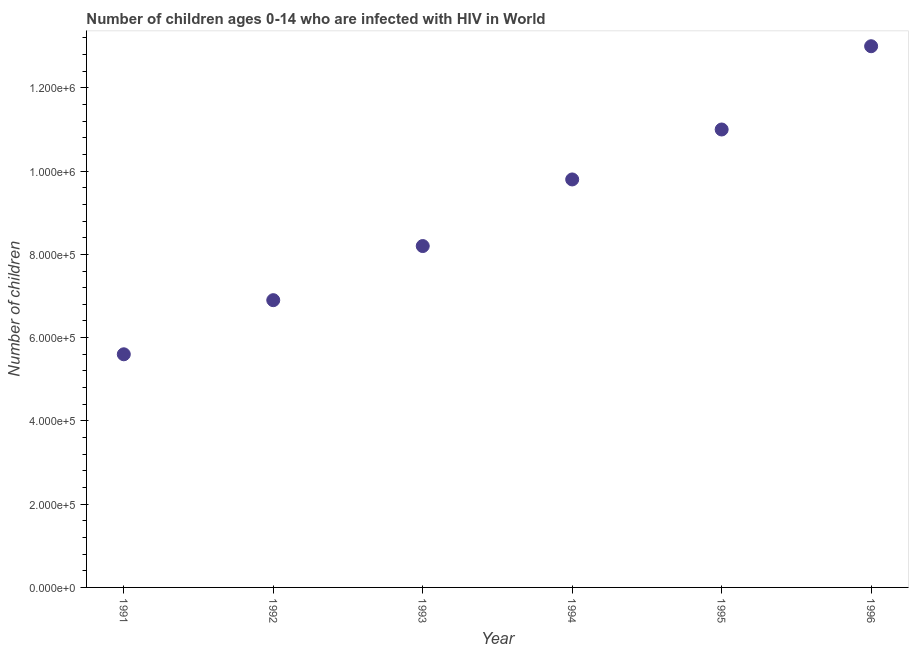What is the number of children living with hiv in 1994?
Offer a terse response. 9.80e+05. Across all years, what is the maximum number of children living with hiv?
Your response must be concise. 1.30e+06. Across all years, what is the minimum number of children living with hiv?
Provide a succinct answer. 5.60e+05. In which year was the number of children living with hiv minimum?
Your answer should be very brief. 1991. What is the sum of the number of children living with hiv?
Your response must be concise. 5.45e+06. What is the difference between the number of children living with hiv in 1995 and 1996?
Your response must be concise. -2.00e+05. What is the average number of children living with hiv per year?
Your answer should be compact. 9.08e+05. In how many years, is the number of children living with hiv greater than 160000 ?
Provide a short and direct response. 6. Do a majority of the years between 1994 and 1993 (inclusive) have number of children living with hiv greater than 160000 ?
Your answer should be very brief. No. What is the ratio of the number of children living with hiv in 1994 to that in 1995?
Make the answer very short. 0.89. Is the number of children living with hiv in 1993 less than that in 1996?
Keep it short and to the point. Yes. What is the difference between the highest and the second highest number of children living with hiv?
Offer a terse response. 2.00e+05. Is the sum of the number of children living with hiv in 1991 and 1996 greater than the maximum number of children living with hiv across all years?
Your answer should be very brief. Yes. What is the difference between the highest and the lowest number of children living with hiv?
Provide a short and direct response. 7.40e+05. Does the number of children living with hiv monotonically increase over the years?
Offer a very short reply. Yes. How many years are there in the graph?
Give a very brief answer. 6. What is the difference between two consecutive major ticks on the Y-axis?
Your response must be concise. 2.00e+05. Does the graph contain any zero values?
Your answer should be compact. No. What is the title of the graph?
Keep it short and to the point. Number of children ages 0-14 who are infected with HIV in World. What is the label or title of the X-axis?
Provide a short and direct response. Year. What is the label or title of the Y-axis?
Provide a succinct answer. Number of children. What is the Number of children in 1991?
Provide a succinct answer. 5.60e+05. What is the Number of children in 1992?
Your answer should be very brief. 6.90e+05. What is the Number of children in 1993?
Make the answer very short. 8.20e+05. What is the Number of children in 1994?
Offer a terse response. 9.80e+05. What is the Number of children in 1995?
Provide a short and direct response. 1.10e+06. What is the Number of children in 1996?
Your answer should be compact. 1.30e+06. What is the difference between the Number of children in 1991 and 1992?
Keep it short and to the point. -1.30e+05. What is the difference between the Number of children in 1991 and 1993?
Give a very brief answer. -2.60e+05. What is the difference between the Number of children in 1991 and 1994?
Keep it short and to the point. -4.20e+05. What is the difference between the Number of children in 1991 and 1995?
Ensure brevity in your answer.  -5.40e+05. What is the difference between the Number of children in 1991 and 1996?
Offer a terse response. -7.40e+05. What is the difference between the Number of children in 1992 and 1993?
Your answer should be compact. -1.30e+05. What is the difference between the Number of children in 1992 and 1995?
Ensure brevity in your answer.  -4.10e+05. What is the difference between the Number of children in 1992 and 1996?
Ensure brevity in your answer.  -6.10e+05. What is the difference between the Number of children in 1993 and 1994?
Provide a succinct answer. -1.60e+05. What is the difference between the Number of children in 1993 and 1995?
Offer a terse response. -2.80e+05. What is the difference between the Number of children in 1993 and 1996?
Ensure brevity in your answer.  -4.80e+05. What is the difference between the Number of children in 1994 and 1996?
Give a very brief answer. -3.20e+05. What is the ratio of the Number of children in 1991 to that in 1992?
Offer a terse response. 0.81. What is the ratio of the Number of children in 1991 to that in 1993?
Your answer should be very brief. 0.68. What is the ratio of the Number of children in 1991 to that in 1994?
Make the answer very short. 0.57. What is the ratio of the Number of children in 1991 to that in 1995?
Keep it short and to the point. 0.51. What is the ratio of the Number of children in 1991 to that in 1996?
Your answer should be very brief. 0.43. What is the ratio of the Number of children in 1992 to that in 1993?
Keep it short and to the point. 0.84. What is the ratio of the Number of children in 1992 to that in 1994?
Provide a succinct answer. 0.7. What is the ratio of the Number of children in 1992 to that in 1995?
Give a very brief answer. 0.63. What is the ratio of the Number of children in 1992 to that in 1996?
Your answer should be very brief. 0.53. What is the ratio of the Number of children in 1993 to that in 1994?
Provide a succinct answer. 0.84. What is the ratio of the Number of children in 1993 to that in 1995?
Keep it short and to the point. 0.74. What is the ratio of the Number of children in 1993 to that in 1996?
Provide a short and direct response. 0.63. What is the ratio of the Number of children in 1994 to that in 1995?
Ensure brevity in your answer.  0.89. What is the ratio of the Number of children in 1994 to that in 1996?
Ensure brevity in your answer.  0.75. What is the ratio of the Number of children in 1995 to that in 1996?
Provide a succinct answer. 0.85. 